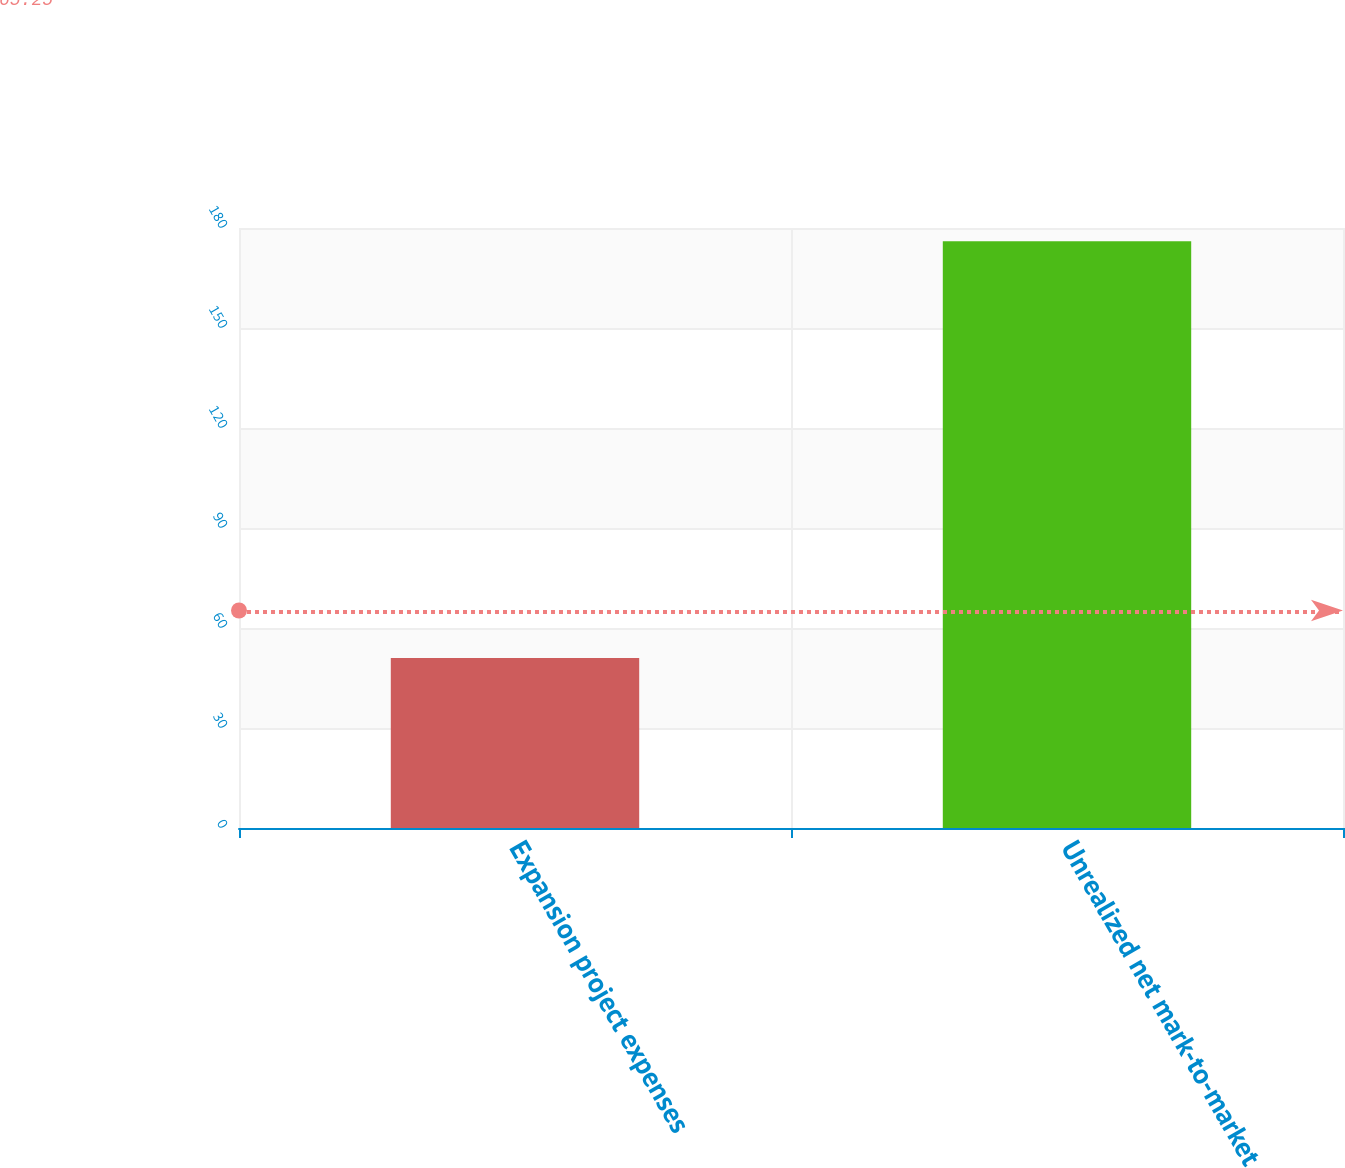<chart> <loc_0><loc_0><loc_500><loc_500><bar_chart><fcel>Expansion project expenses<fcel>Unrealized net mark-to-market<nl><fcel>51<fcel>176<nl></chart> 